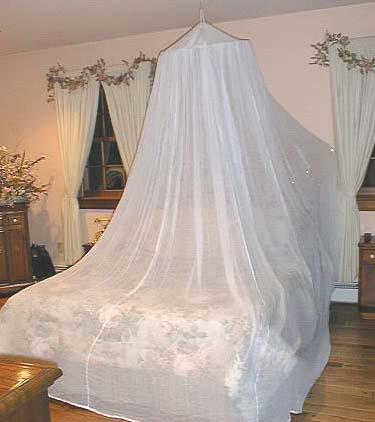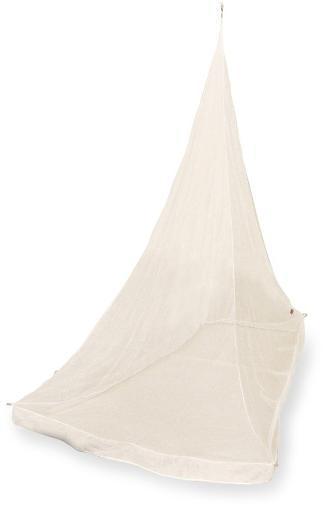The first image is the image on the left, the second image is the image on the right. Given the left and right images, does the statement "Green netting hangs over two cots in one of the images." hold true? Answer yes or no. No. The first image is the image on the left, the second image is the image on the right. Assess this claim about the two images: "There are two canopies and at least one is green a square.". Correct or not? Answer yes or no. No. 